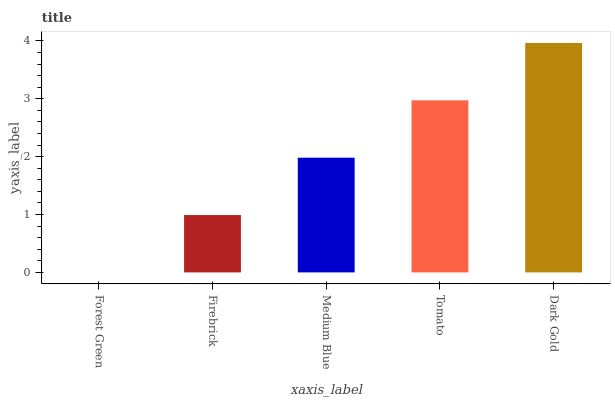Is Forest Green the minimum?
Answer yes or no. Yes. Is Dark Gold the maximum?
Answer yes or no. Yes. Is Firebrick the minimum?
Answer yes or no. No. Is Firebrick the maximum?
Answer yes or no. No. Is Firebrick greater than Forest Green?
Answer yes or no. Yes. Is Forest Green less than Firebrick?
Answer yes or no. Yes. Is Forest Green greater than Firebrick?
Answer yes or no. No. Is Firebrick less than Forest Green?
Answer yes or no. No. Is Medium Blue the high median?
Answer yes or no. Yes. Is Medium Blue the low median?
Answer yes or no. Yes. Is Forest Green the high median?
Answer yes or no. No. Is Firebrick the low median?
Answer yes or no. No. 